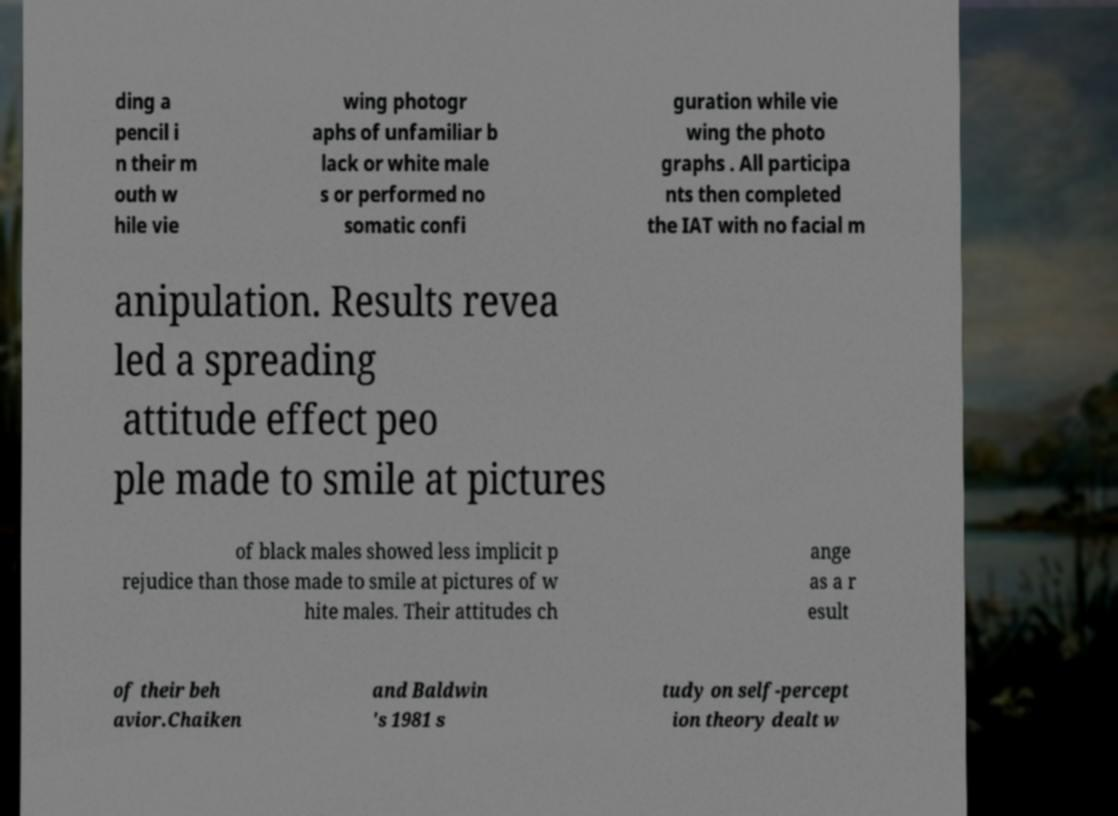Please read and relay the text visible in this image. What does it say? ding a pencil i n their m outh w hile vie wing photogr aphs of unfamiliar b lack or white male s or performed no somatic confi guration while vie wing the photo graphs . All participa nts then completed the IAT with no facial m anipulation. Results revea led a spreading attitude effect peo ple made to smile at pictures of black males showed less implicit p rejudice than those made to smile at pictures of w hite males. Their attitudes ch ange as a r esult of their beh avior.Chaiken and Baldwin 's 1981 s tudy on self-percept ion theory dealt w 